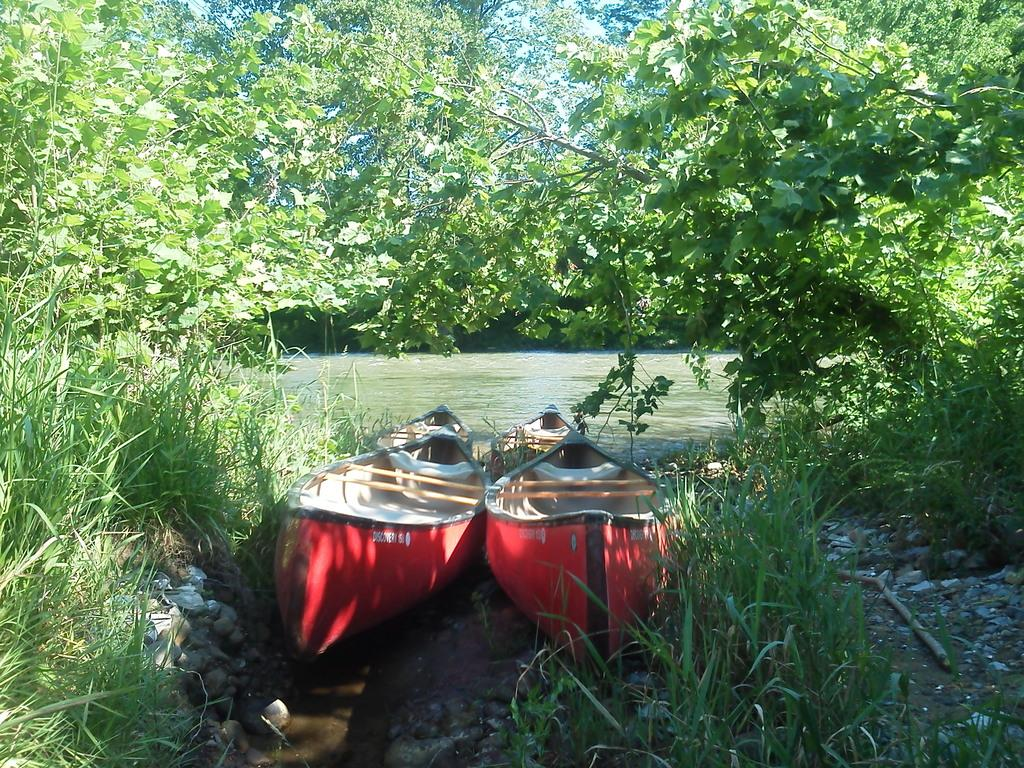How many boats can be seen in the image? There are two boats in the image. What colors are the boats? The boats are in red and white colors. What type of vegetation is visible on both sides of the image? There are trees visible on both sides of the image. What is the primary element visible in the image? There is water visible in the image. Where is the turkey located in the image? There is no turkey present in the image. What type of cactus can be seen growing near the boats? There are no cacti visible in the image; only trees are present. 